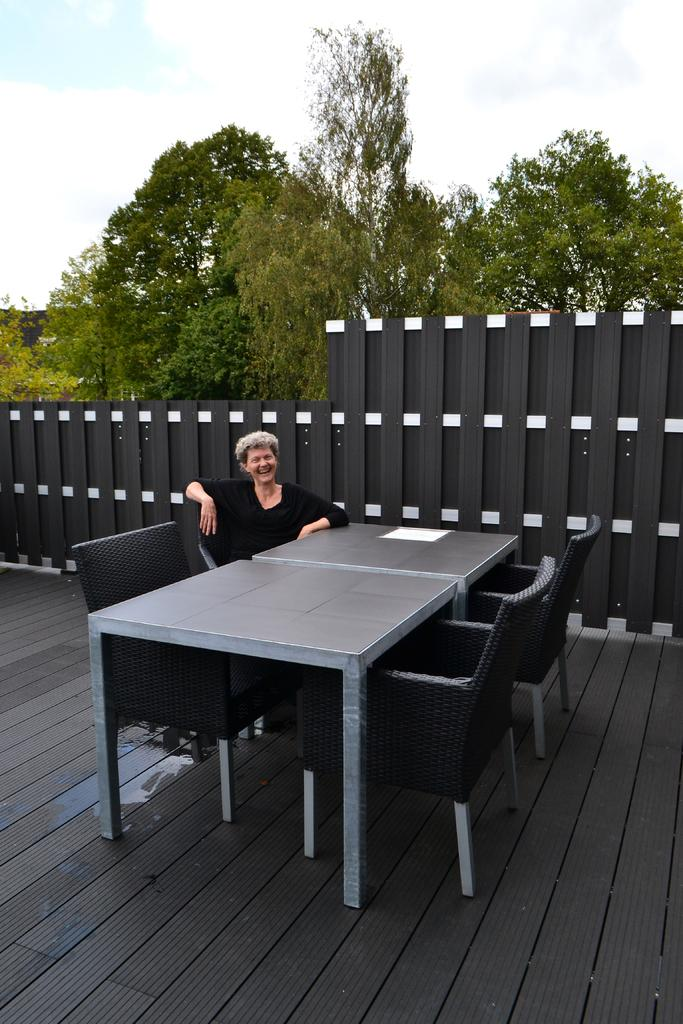What is the person in the image doing? The person is sitting in the image. Where is the person sitting in relation to other objects? The person is sitting in front of a table. What can be seen behind the person? There is a railing behind the person. What type of natural scenery is visible in the background of the image? There are trees in the background of the image. What else can be seen in the background of the image? The sky is visible in the background of the image. What theory is the person discussing with the curtain in the image? There is no curtain present in the image, and the person is not discussing any theories. 